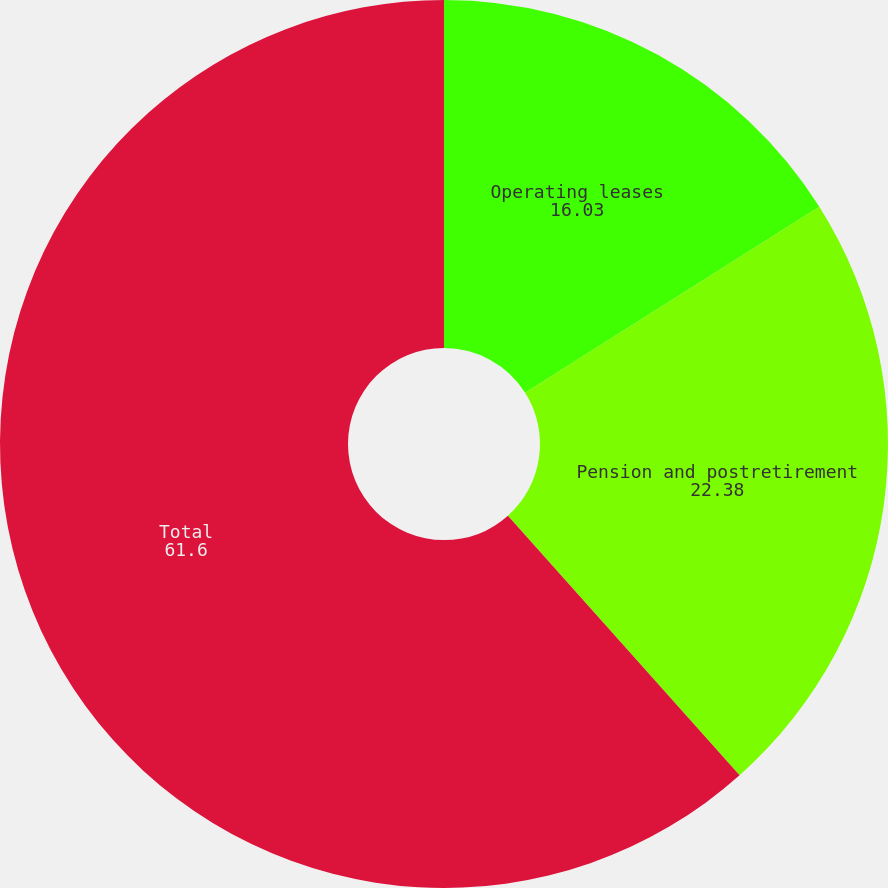Convert chart. <chart><loc_0><loc_0><loc_500><loc_500><pie_chart><fcel>Operating leases<fcel>Pension and postretirement<fcel>Total<nl><fcel>16.03%<fcel>22.38%<fcel>61.6%<nl></chart> 